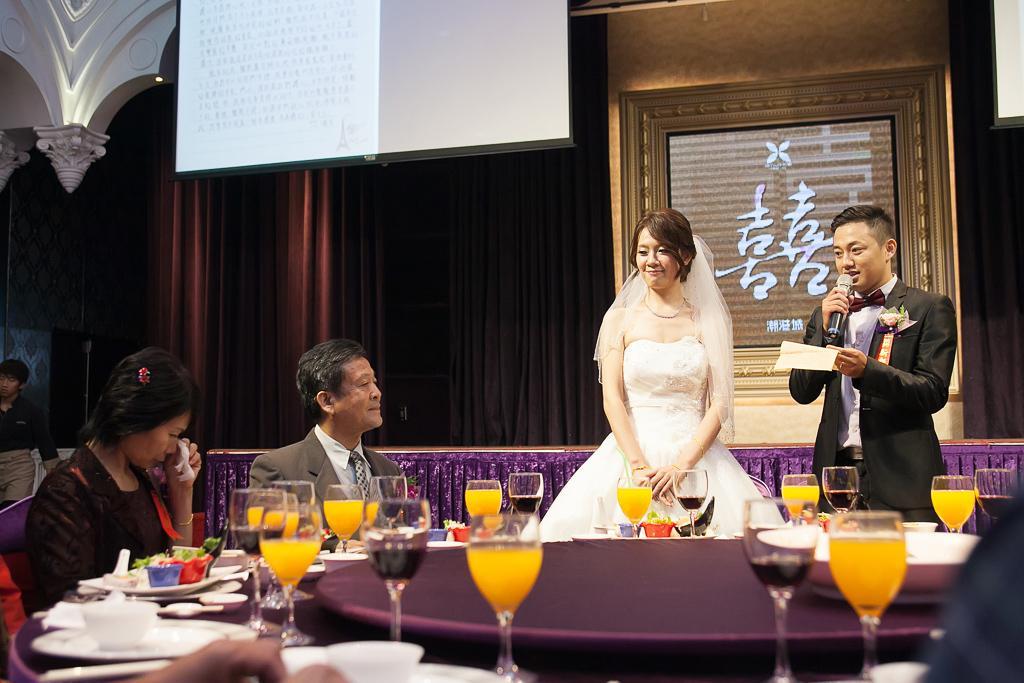In one or two sentences, can you explain what this image depicts? In this picture we can see a woman and a man standing on the floor. And this is the table. And here we can see two persons sitting on the chairs. And on the background there is a curtain, and this is the wall. And there is a screen. And even we can see juice glasses on the table. 